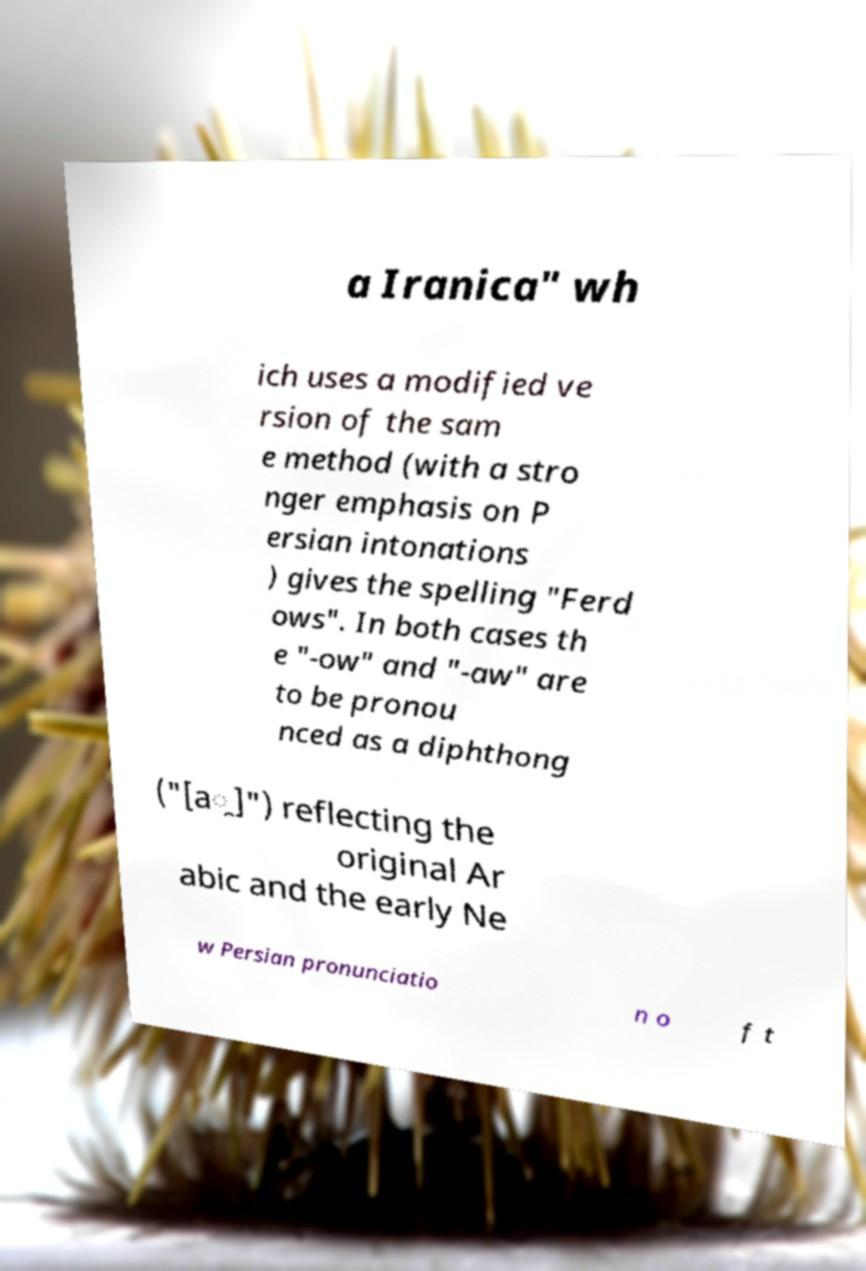Please read and relay the text visible in this image. What does it say? a Iranica" wh ich uses a modified ve rsion of the sam e method (with a stro nger emphasis on P ersian intonations ) gives the spelling "Ferd ows". In both cases th e "-ow" and "-aw" are to be pronou nced as a diphthong ("[a̯]") reflecting the original Ar abic and the early Ne w Persian pronunciatio n o f t 